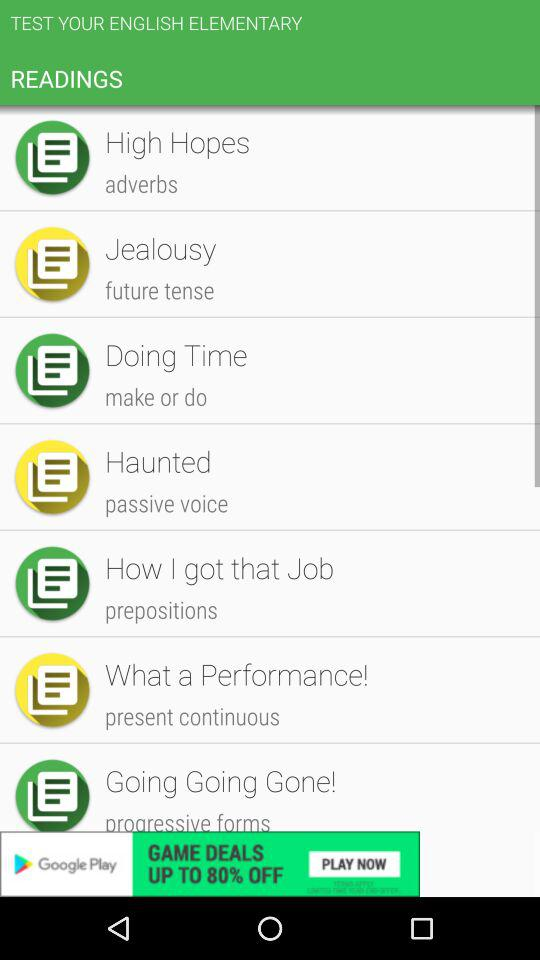Write a word of adverbs? A word of adverbs is "High Hopes". 